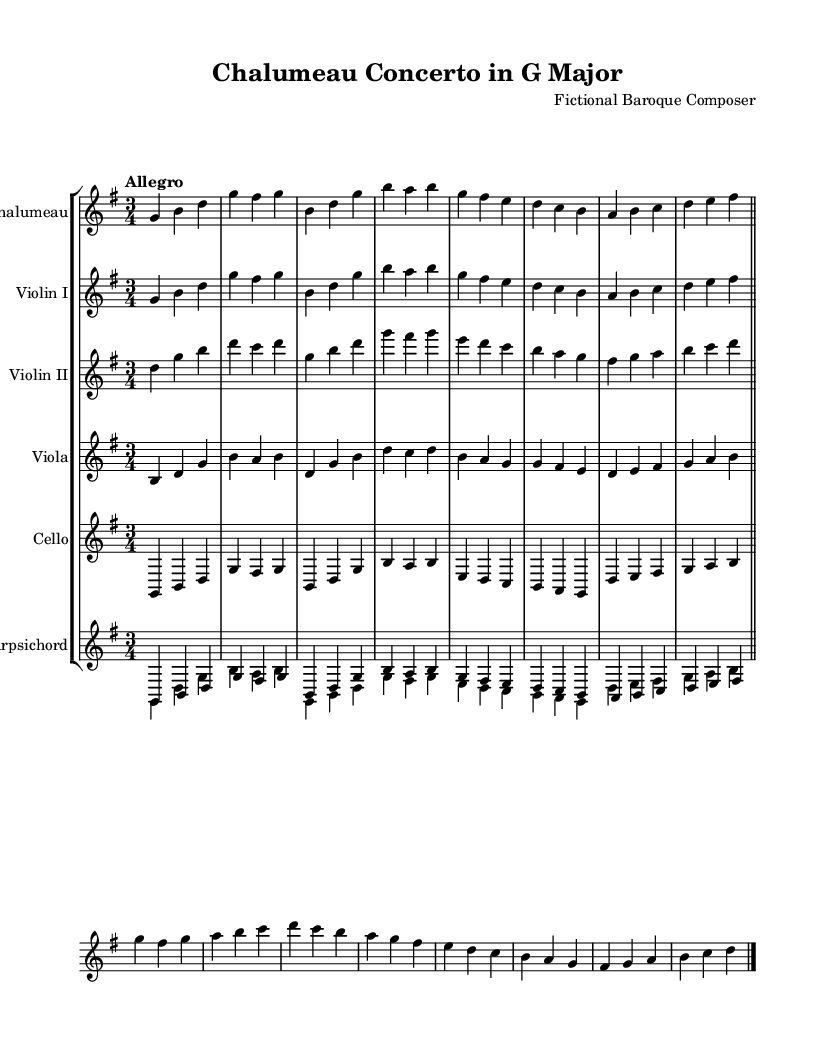What is the key signature of this music? The key signature displayed in the sheet music shows one sharp, indicating it is in G major.
Answer: G major What is the time signature of this piece? The time signature is indicated as 3/4, which means there are three beats in each measure and the quarter note gets one beat.
Answer: 3/4 What is the tempo marking for the piece? The tempo marking is "Allegro," which suggests a brisk and lively tempo.
Answer: Allegro How many instrumental parts are available in this concerto? The sheet music features five instrumental parts: chalumeau, two violins, viola, and cello, along with a harpsichord accompaniment.
Answer: Five Which instrument plays the melody in the first few measures? The chalumeau plays the melody in the first few measures, as indicated by the instrument name and the notes written in its staff.
Answer: Chalumeau What compositional form is predominantly used in this piece? The structure of the concerto suggests a ritornello form, where the main theme is repeated and alternated with contrasting episodes.
Answer: Ritornello What is the role of the harpsichord in this concerto? The harpsichord functions as a continuo instrument, providing harmonic support and embellishment throughout the piece.
Answer: Continuo 